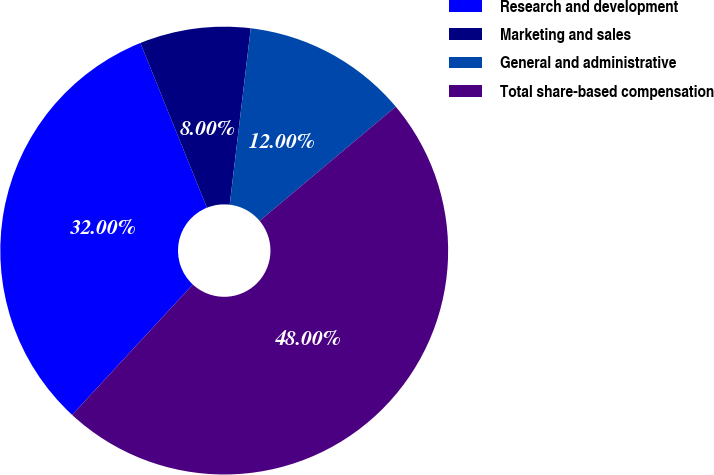Convert chart to OTSL. <chart><loc_0><loc_0><loc_500><loc_500><pie_chart><fcel>Research and development<fcel>Marketing and sales<fcel>General and administrative<fcel>Total share-based compensation<nl><fcel>32.0%<fcel>8.0%<fcel>12.0%<fcel>48.0%<nl></chart> 